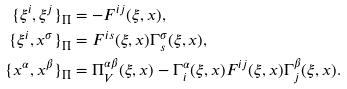Convert formula to latex. <formula><loc_0><loc_0><loc_500><loc_500>\{ \xi ^ { i } , \xi ^ { j } \} _ { \Pi } & = - F ^ { i j } ( \xi , x ) , \\ \{ \xi ^ { i } , x ^ { \sigma } \} _ { \Pi } & = F ^ { i s } ( \xi , x ) \Gamma _ { s } ^ { \sigma } ( \xi , x ) , \\ \{ x ^ { \alpha } , x ^ { \beta } \} _ { \Pi } & = \Pi _ { V } ^ { \alpha \beta } ( \xi , x ) - \Gamma _ { i } ^ { \alpha } ( \xi , x ) F ^ { i j } ( \xi , x ) \Gamma _ { j } ^ { \beta } ( \xi , x ) .</formula> 